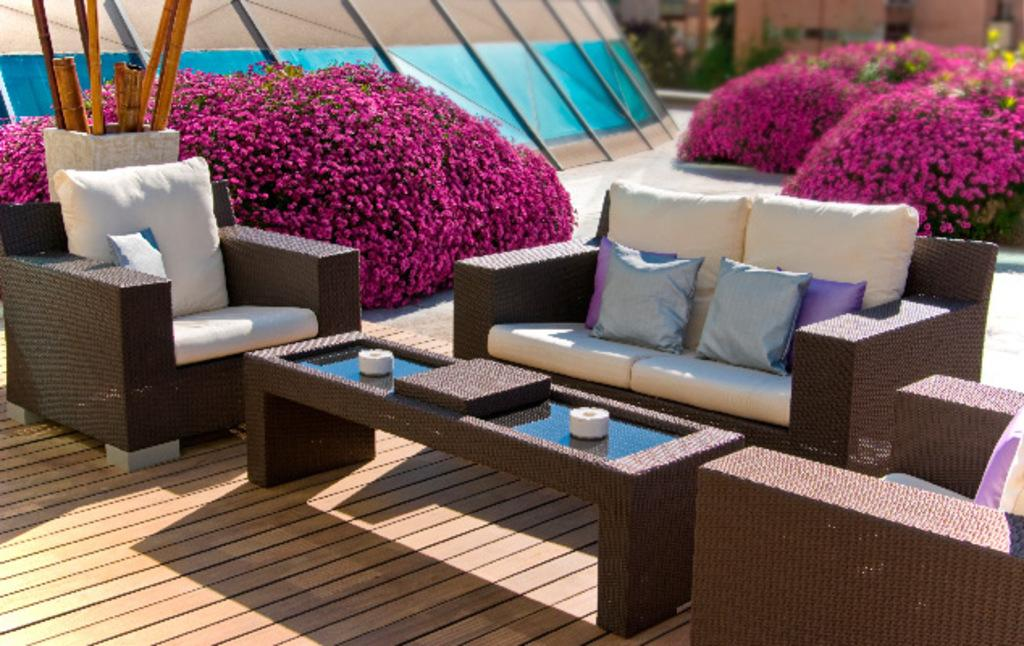What type of setting is depicted in the image? The image is an outdoor scene. What kind of vegetation can be seen in the image? There are plants with flowers in the image. What type of furniture is present in the image? There is a couch with pillows in the image. What other objects can be seen on the table in the image? There is a box on the table in the image. What is the purpose of the object next to the table in the image? There is a musical instrument holder in the image, which is used for holding musical instruments. What does the caption on the box say in the image? There is no caption on the box in the image, as it is not mentioned in the provided facts. 